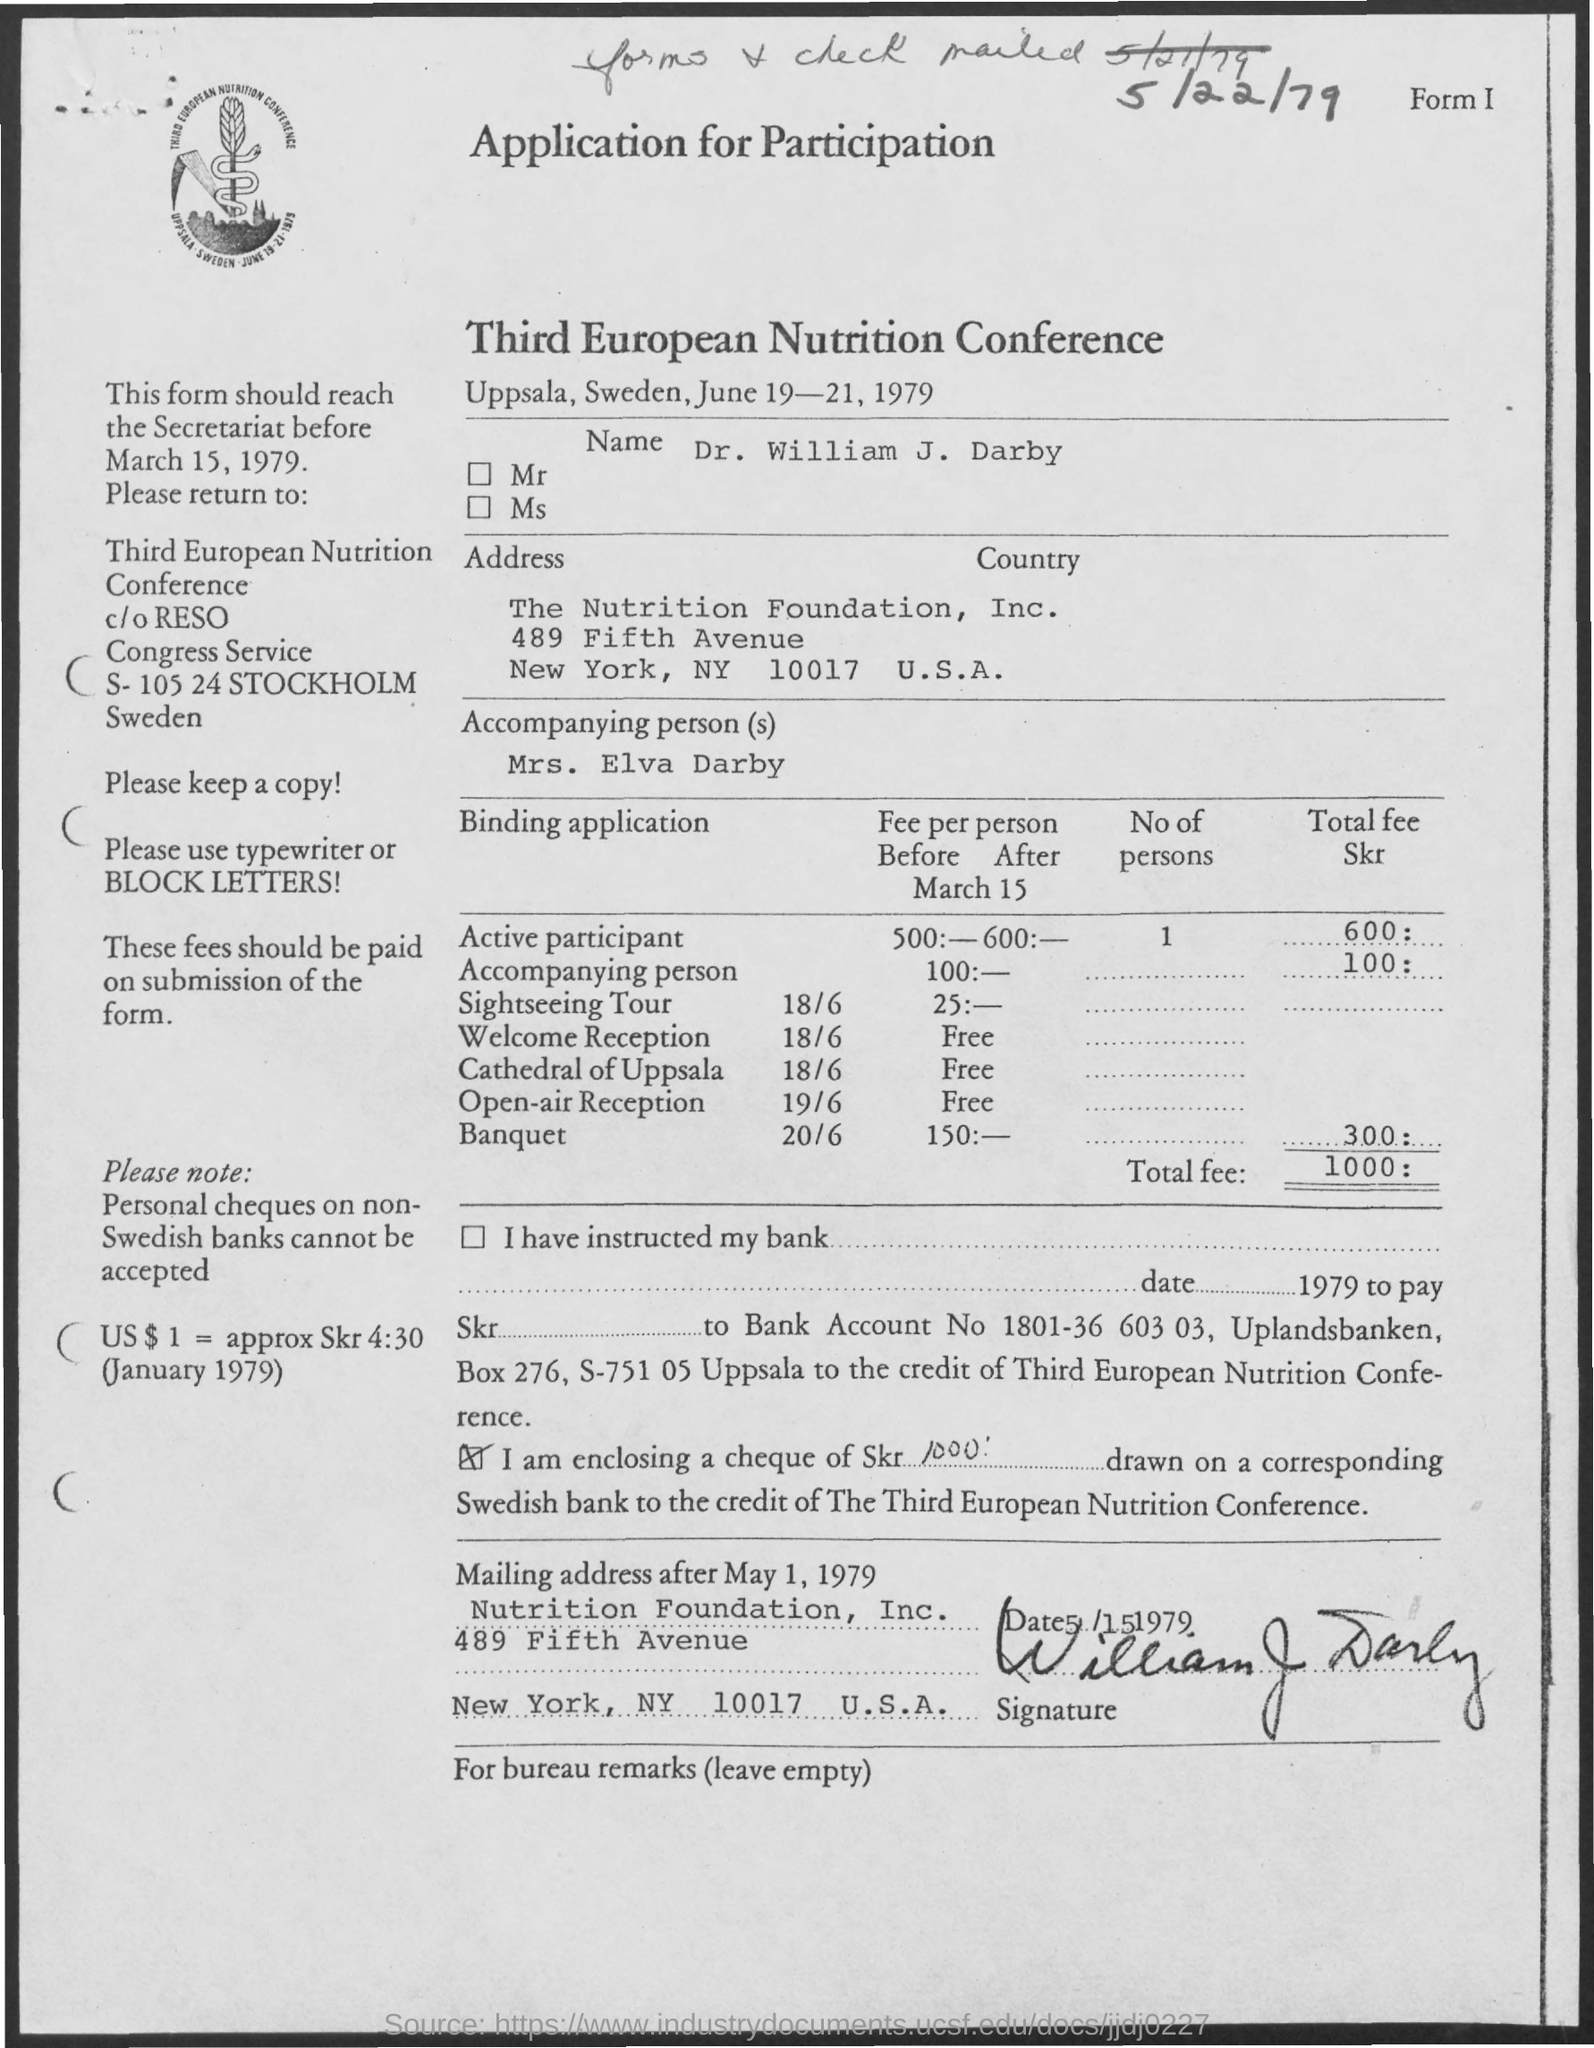Outline some significant characteristics in this image. The application mentions a total fee of 1000. The Third European Nutrition Conference was scheduled for June 19-21, 1979. The name mentioned in the given application is Dr. William J. Darby. The name of the conference is the Third European Nutrition Conference. 